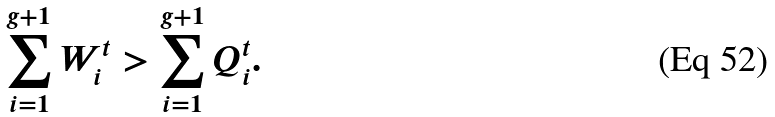Convert formula to latex. <formula><loc_0><loc_0><loc_500><loc_500>\sum _ { i = 1 } ^ { g + 1 } W _ { i } ^ { t } > \sum _ { i = 1 } ^ { g + 1 } Q _ { i } ^ { t } .</formula> 